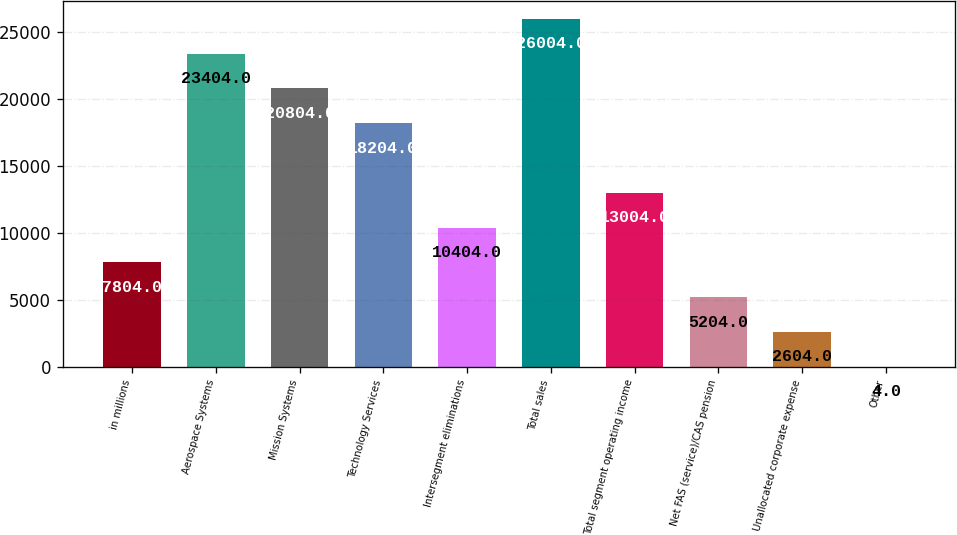Convert chart. <chart><loc_0><loc_0><loc_500><loc_500><bar_chart><fcel>in millions<fcel>Aerospace Systems<fcel>Mission Systems<fcel>Technology Services<fcel>Intersegment eliminations<fcel>Total sales<fcel>Total segment operating income<fcel>Net FAS (service)/CAS pension<fcel>Unallocated corporate expense<fcel>Other<nl><fcel>7804<fcel>23404<fcel>20804<fcel>18204<fcel>10404<fcel>26004<fcel>13004<fcel>5204<fcel>2604<fcel>4<nl></chart> 